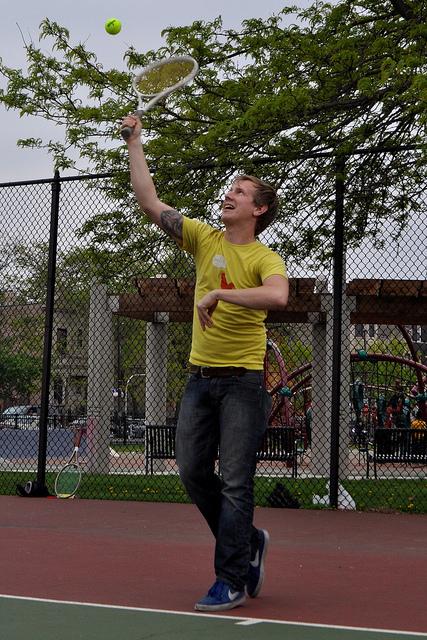What is the man holding?
Answer briefly. Tennis racket. Is the man at a tennis center?
Quick response, please. Yes. Are both feet on the ground?
Keep it brief. No. Is this a professional game?
Give a very brief answer. No. 